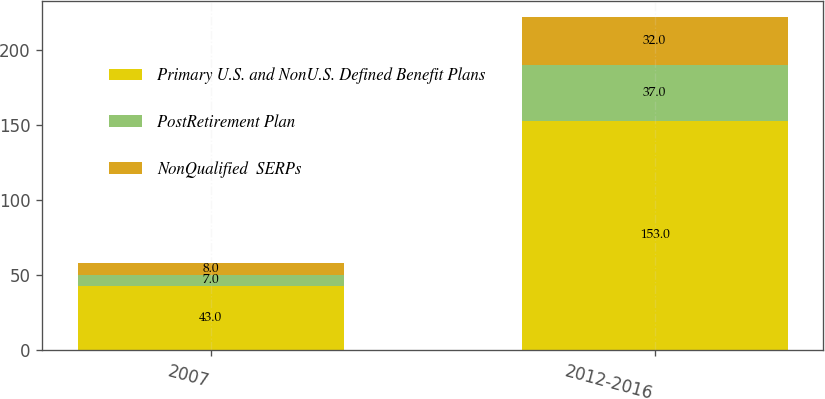Convert chart. <chart><loc_0><loc_0><loc_500><loc_500><stacked_bar_chart><ecel><fcel>2007<fcel>2012-2016<nl><fcel>Primary U.S. and NonU.S. Defined Benefit Plans<fcel>43<fcel>153<nl><fcel>PostRetirement Plan<fcel>7<fcel>37<nl><fcel>NonQualified  SERPs<fcel>8<fcel>32<nl></chart> 